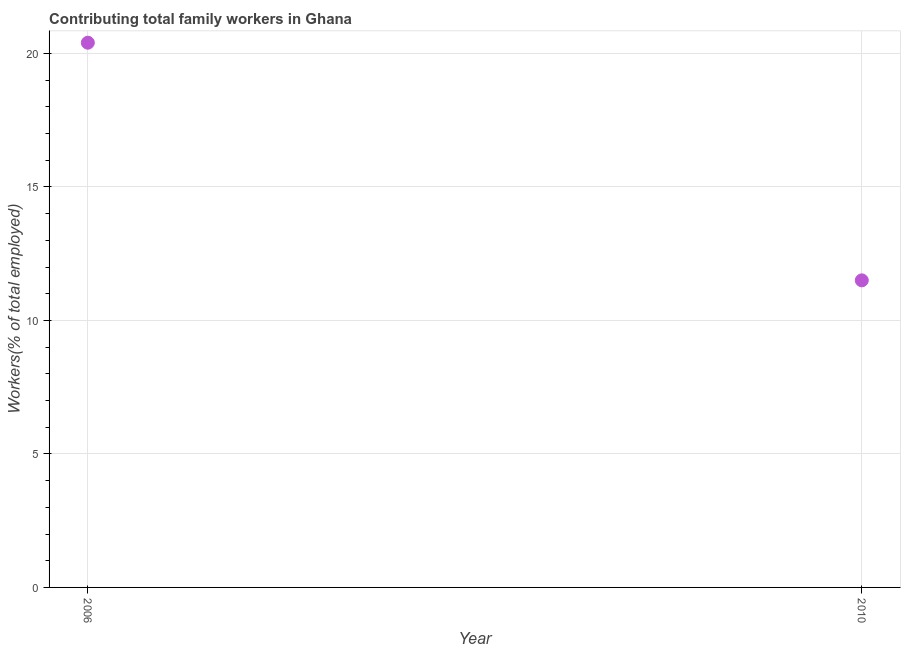What is the contributing family workers in 2006?
Give a very brief answer. 20.4. Across all years, what is the maximum contributing family workers?
Ensure brevity in your answer.  20.4. In which year was the contributing family workers maximum?
Offer a very short reply. 2006. What is the sum of the contributing family workers?
Keep it short and to the point. 31.9. What is the difference between the contributing family workers in 2006 and 2010?
Provide a short and direct response. 8.9. What is the average contributing family workers per year?
Provide a succinct answer. 15.95. What is the median contributing family workers?
Offer a terse response. 15.95. In how many years, is the contributing family workers greater than 10 %?
Keep it short and to the point. 2. What is the ratio of the contributing family workers in 2006 to that in 2010?
Your answer should be very brief. 1.77. Is the contributing family workers in 2006 less than that in 2010?
Make the answer very short. No. Does the contributing family workers monotonically increase over the years?
Keep it short and to the point. No. How many dotlines are there?
Ensure brevity in your answer.  1. Are the values on the major ticks of Y-axis written in scientific E-notation?
Your response must be concise. No. Does the graph contain any zero values?
Make the answer very short. No. Does the graph contain grids?
Give a very brief answer. Yes. What is the title of the graph?
Give a very brief answer. Contributing total family workers in Ghana. What is the label or title of the X-axis?
Your response must be concise. Year. What is the label or title of the Y-axis?
Give a very brief answer. Workers(% of total employed). What is the Workers(% of total employed) in 2006?
Ensure brevity in your answer.  20.4. What is the Workers(% of total employed) in 2010?
Keep it short and to the point. 11.5. What is the difference between the Workers(% of total employed) in 2006 and 2010?
Your answer should be very brief. 8.9. What is the ratio of the Workers(% of total employed) in 2006 to that in 2010?
Provide a short and direct response. 1.77. 